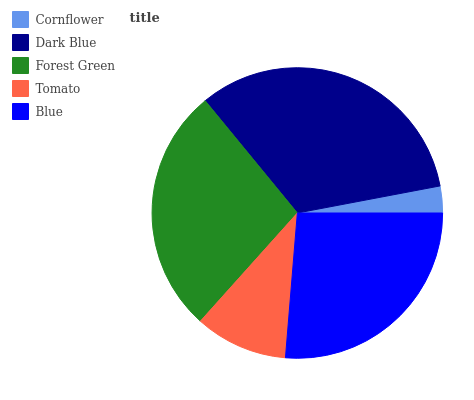Is Cornflower the minimum?
Answer yes or no. Yes. Is Dark Blue the maximum?
Answer yes or no. Yes. Is Forest Green the minimum?
Answer yes or no. No. Is Forest Green the maximum?
Answer yes or no. No. Is Dark Blue greater than Forest Green?
Answer yes or no. Yes. Is Forest Green less than Dark Blue?
Answer yes or no. Yes. Is Forest Green greater than Dark Blue?
Answer yes or no. No. Is Dark Blue less than Forest Green?
Answer yes or no. No. Is Blue the high median?
Answer yes or no. Yes. Is Blue the low median?
Answer yes or no. Yes. Is Tomato the high median?
Answer yes or no. No. Is Forest Green the low median?
Answer yes or no. No. 